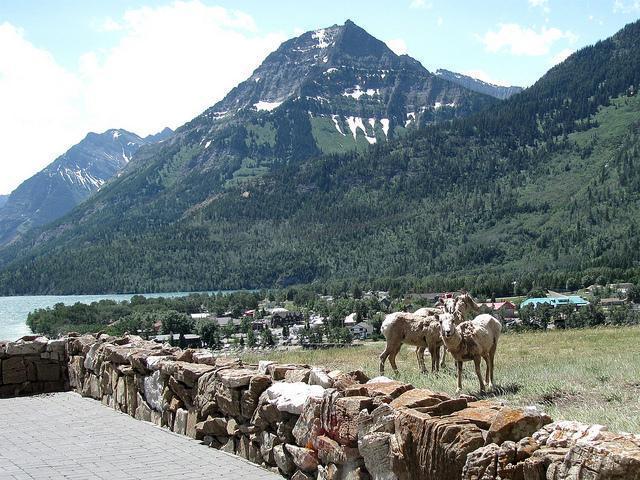How many sheep can you see?
Give a very brief answer. 2. How many people are wearing glasses?
Give a very brief answer. 0. 